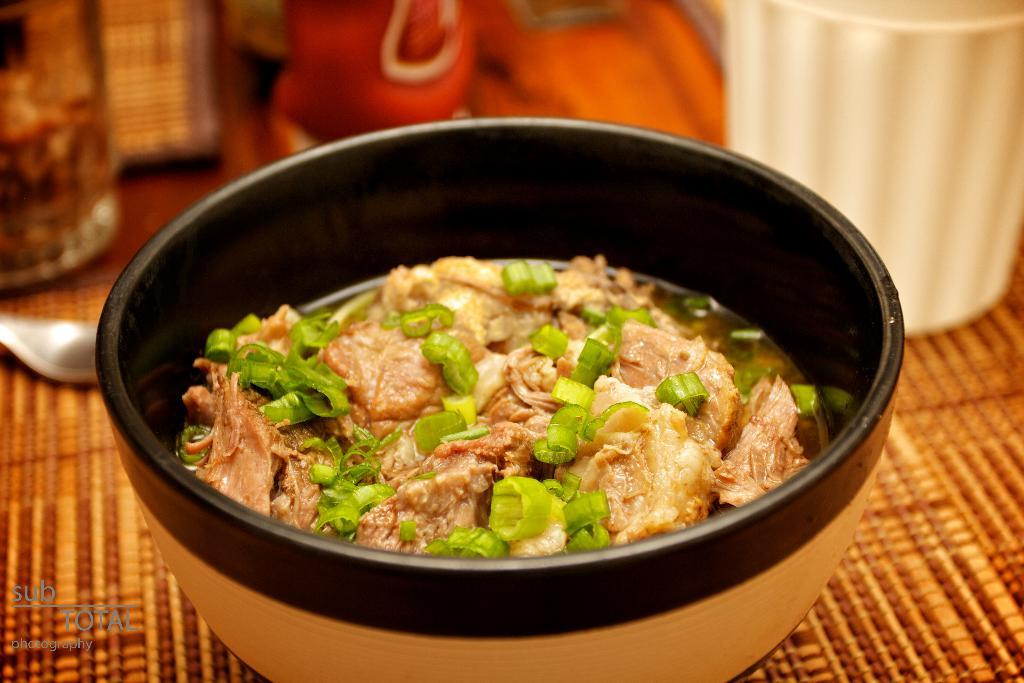What is located in the center of the image? There is a bowl in the center of the image. What is inside the bowl? The bowl contains food items. What else can be seen in the image besides the bowl? There are containers at the top side of the image. What color is the crayon being used by the boys in the image? There are no boys or crayons present in the image. 